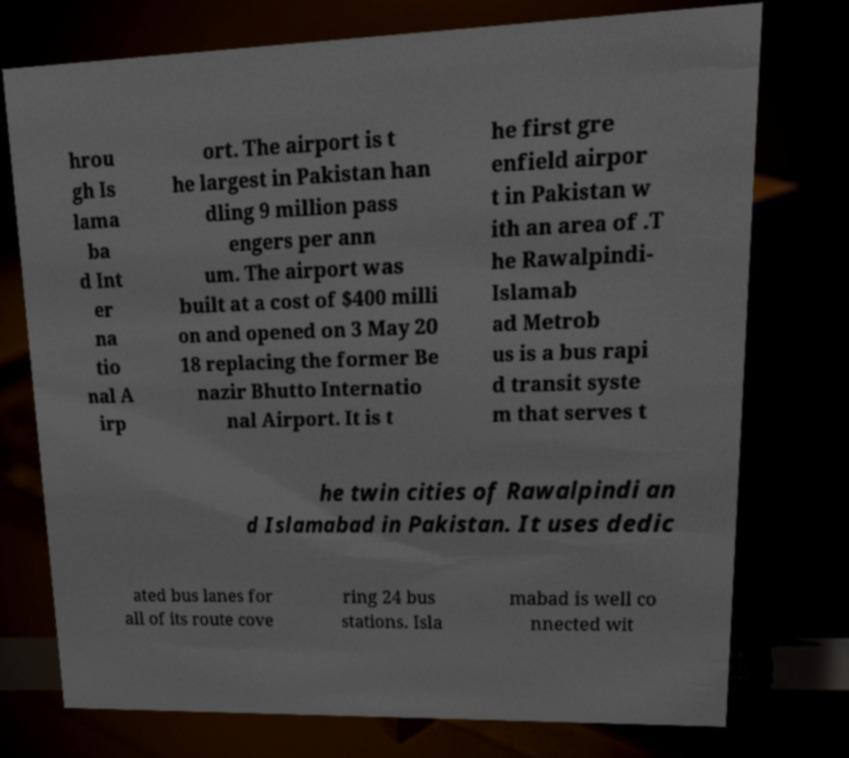Can you read and provide the text displayed in the image?This photo seems to have some interesting text. Can you extract and type it out for me? hrou gh Is lama ba d Int er na tio nal A irp ort. The airport is t he largest in Pakistan han dling 9 million pass engers per ann um. The airport was built at a cost of $400 milli on and opened on 3 May 20 18 replacing the former Be nazir Bhutto Internatio nal Airport. It is t he first gre enfield airpor t in Pakistan w ith an area of .T he Rawalpindi- Islamab ad Metrob us is a bus rapi d transit syste m that serves t he twin cities of Rawalpindi an d Islamabad in Pakistan. It uses dedic ated bus lanes for all of its route cove ring 24 bus stations. Isla mabad is well co nnected wit 